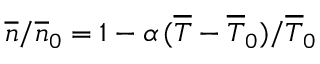<formula> <loc_0><loc_0><loc_500><loc_500>\overline { n } / \overline { n } _ { 0 } = 1 - \alpha \, ( \overline { T } - \overline { T } _ { 0 } ) / \overline { T } _ { 0 }</formula> 